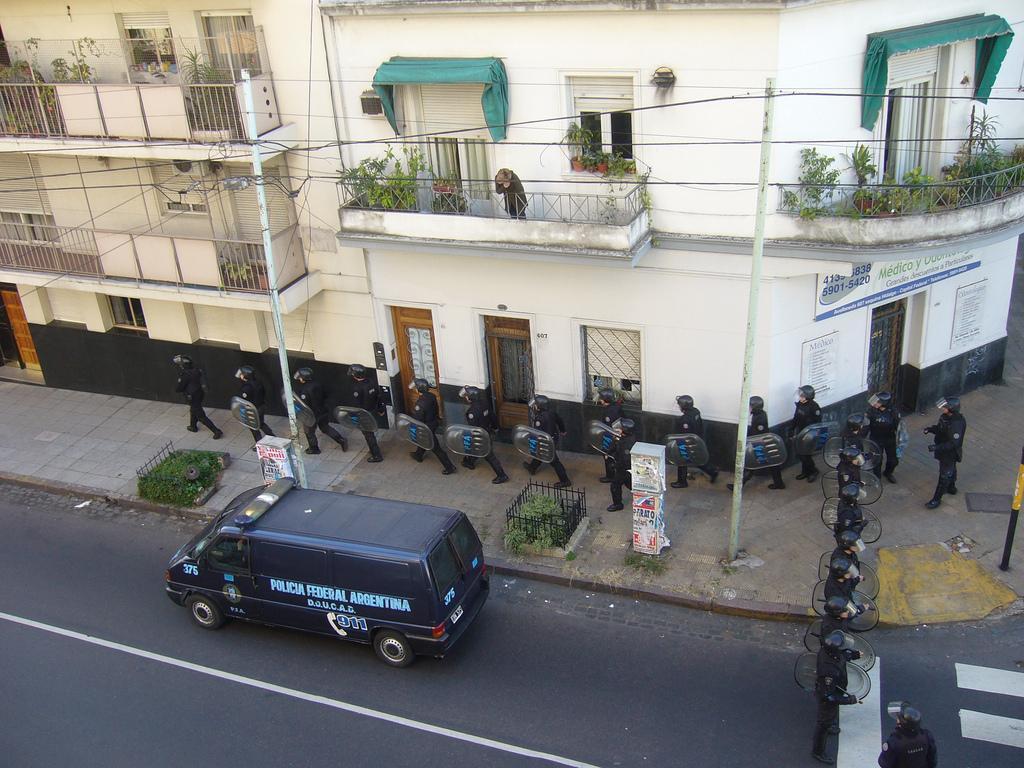Could you give a brief overview of what you see in this image? In this image, we can see the road and there is a van on the road, we can see some persons, there are some buildings. 